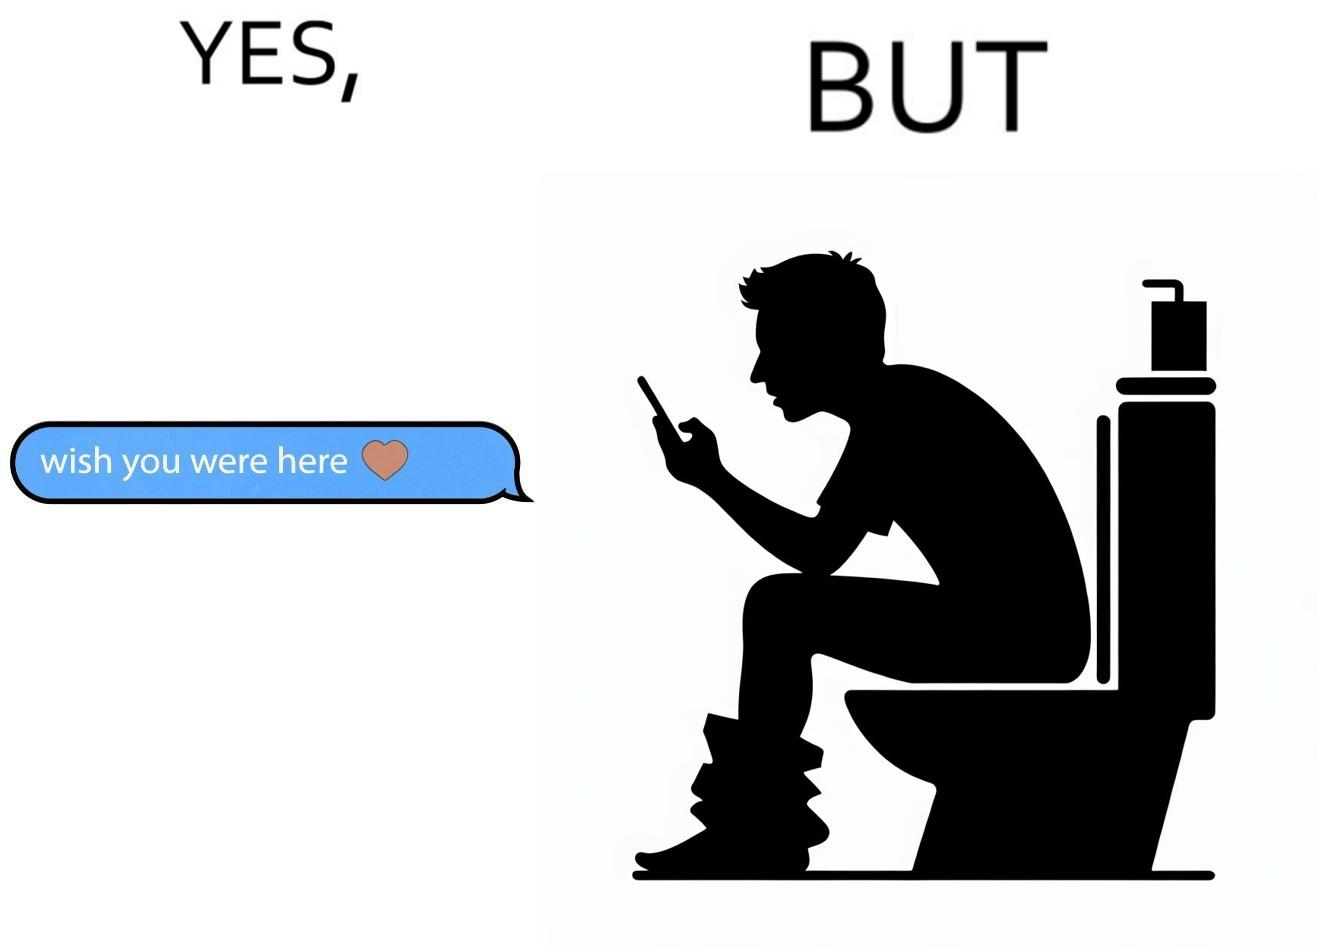Is this a satirical image? Yes, this image is satirical. 